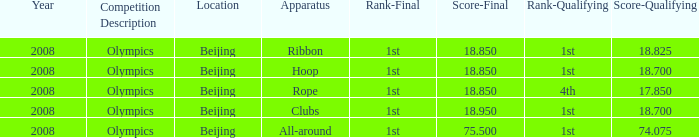What was her final score on the ribbon apparatus? 18.85. 